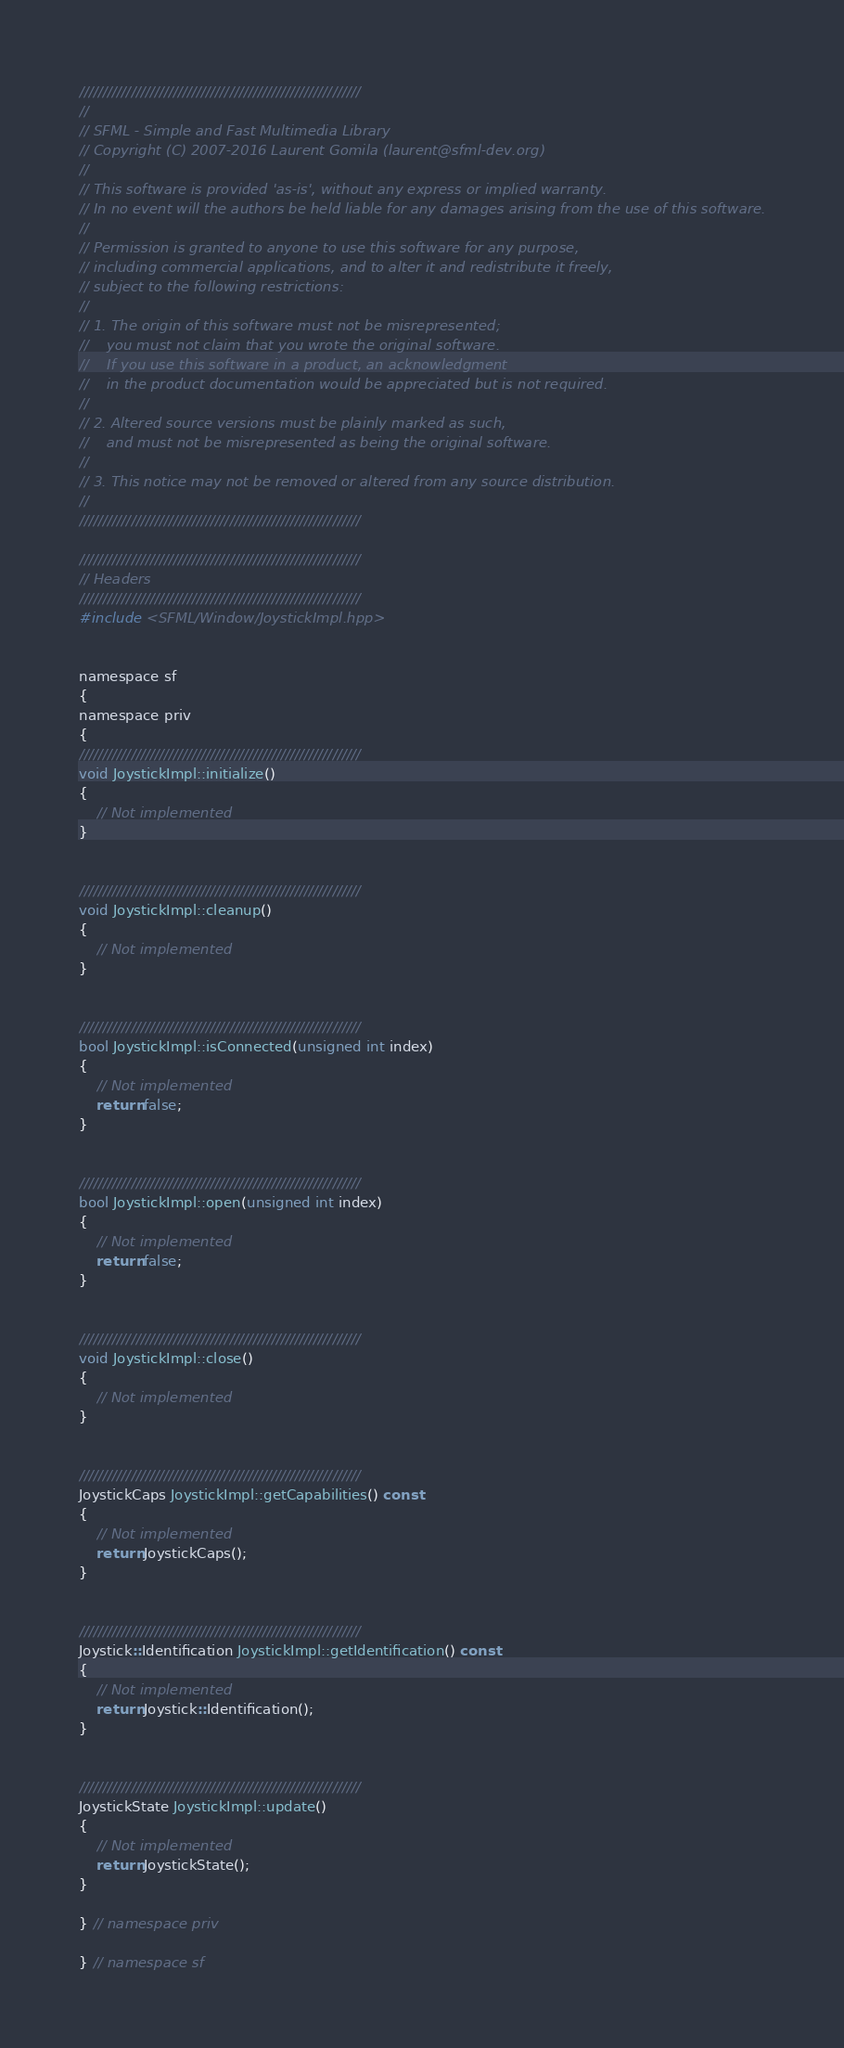<code> <loc_0><loc_0><loc_500><loc_500><_ObjectiveC_>////////////////////////////////////////////////////////////
//
// SFML - Simple and Fast Multimedia Library
// Copyright (C) 2007-2016 Laurent Gomila (laurent@sfml-dev.org)
//
// This software is provided 'as-is', without any express or implied warranty.
// In no event will the authors be held liable for any damages arising from the use of this software.
//
// Permission is granted to anyone to use this software for any purpose,
// including commercial applications, and to alter it and redistribute it freely,
// subject to the following restrictions:
//
// 1. The origin of this software must not be misrepresented;
//    you must not claim that you wrote the original software.
//    If you use this software in a product, an acknowledgment
//    in the product documentation would be appreciated but is not required.
//
// 2. Altered source versions must be plainly marked as such,
//    and must not be misrepresented as being the original software.
//
// 3. This notice may not be removed or altered from any source distribution.
//
////////////////////////////////////////////////////////////

////////////////////////////////////////////////////////////
// Headers
////////////////////////////////////////////////////////////
#include <SFML/Window/JoystickImpl.hpp>


namespace sf
{
namespace priv
{
////////////////////////////////////////////////////////////
void JoystickImpl::initialize()
{
    // Not implemented
}


////////////////////////////////////////////////////////////
void JoystickImpl::cleanup()
{
    // Not implemented
}


////////////////////////////////////////////////////////////
bool JoystickImpl::isConnected(unsigned int index)
{
    // Not implemented
    return false;
}


////////////////////////////////////////////////////////////
bool JoystickImpl::open(unsigned int index)
{
    // Not implemented
    return false;
}


////////////////////////////////////////////////////////////
void JoystickImpl::close()
{
    // Not implemented
}


////////////////////////////////////////////////////////////
JoystickCaps JoystickImpl::getCapabilities() const
{
    // Not implemented
    return JoystickCaps();
}


////////////////////////////////////////////////////////////
Joystick::Identification JoystickImpl::getIdentification() const
{
    // Not implemented
    return Joystick::Identification();
}


////////////////////////////////////////////////////////////
JoystickState JoystickImpl::update()
{
    // Not implemented
    return JoystickState();
}

} // namespace priv

} // namespace sf
</code> 